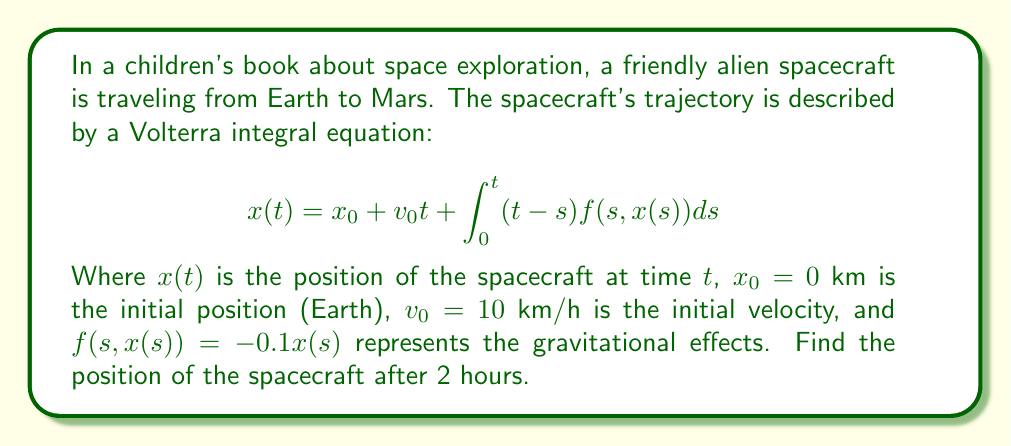Could you help me with this problem? To solve this problem, we'll use an iterative method to approximate the solution:

1) Start with an initial guess for $x(t)$. Let's use $x_0(t) = x_0 + v_0t = 0 + 10t$.

2) Substitute this into the integral equation to get a better approximation:

   $$x_1(t) = 0 + 10t + \int_0^t (t-s)(-0.1(0 + 10s))ds$$

3) Evaluate the integral:
   
   $$x_1(t) = 10t - 0.1\int_0^t (10ts - 10s^2)ds$$
   $$= 10t - 0.1[5ts^2 - \frac{10}{3}s^3]_0^t$$
   $$= 10t - 0.1(5t^3 - \frac{10}{3}t^3)$$
   $$= 10t - \frac{1}{3}t^3$$

4) For $t = 2$ hours:

   $$x_1(2) = 10(2) - \frac{1}{3}(2^3) = 20 - \frac{8}{3} = \frac{52}{3} \approx 17.33$$

5) We could continue this process to get more accurate results, but this first approximation is usually sufficient for simple problems.
Answer: $\frac{52}{3}$ km (approximately 17.33 km) 